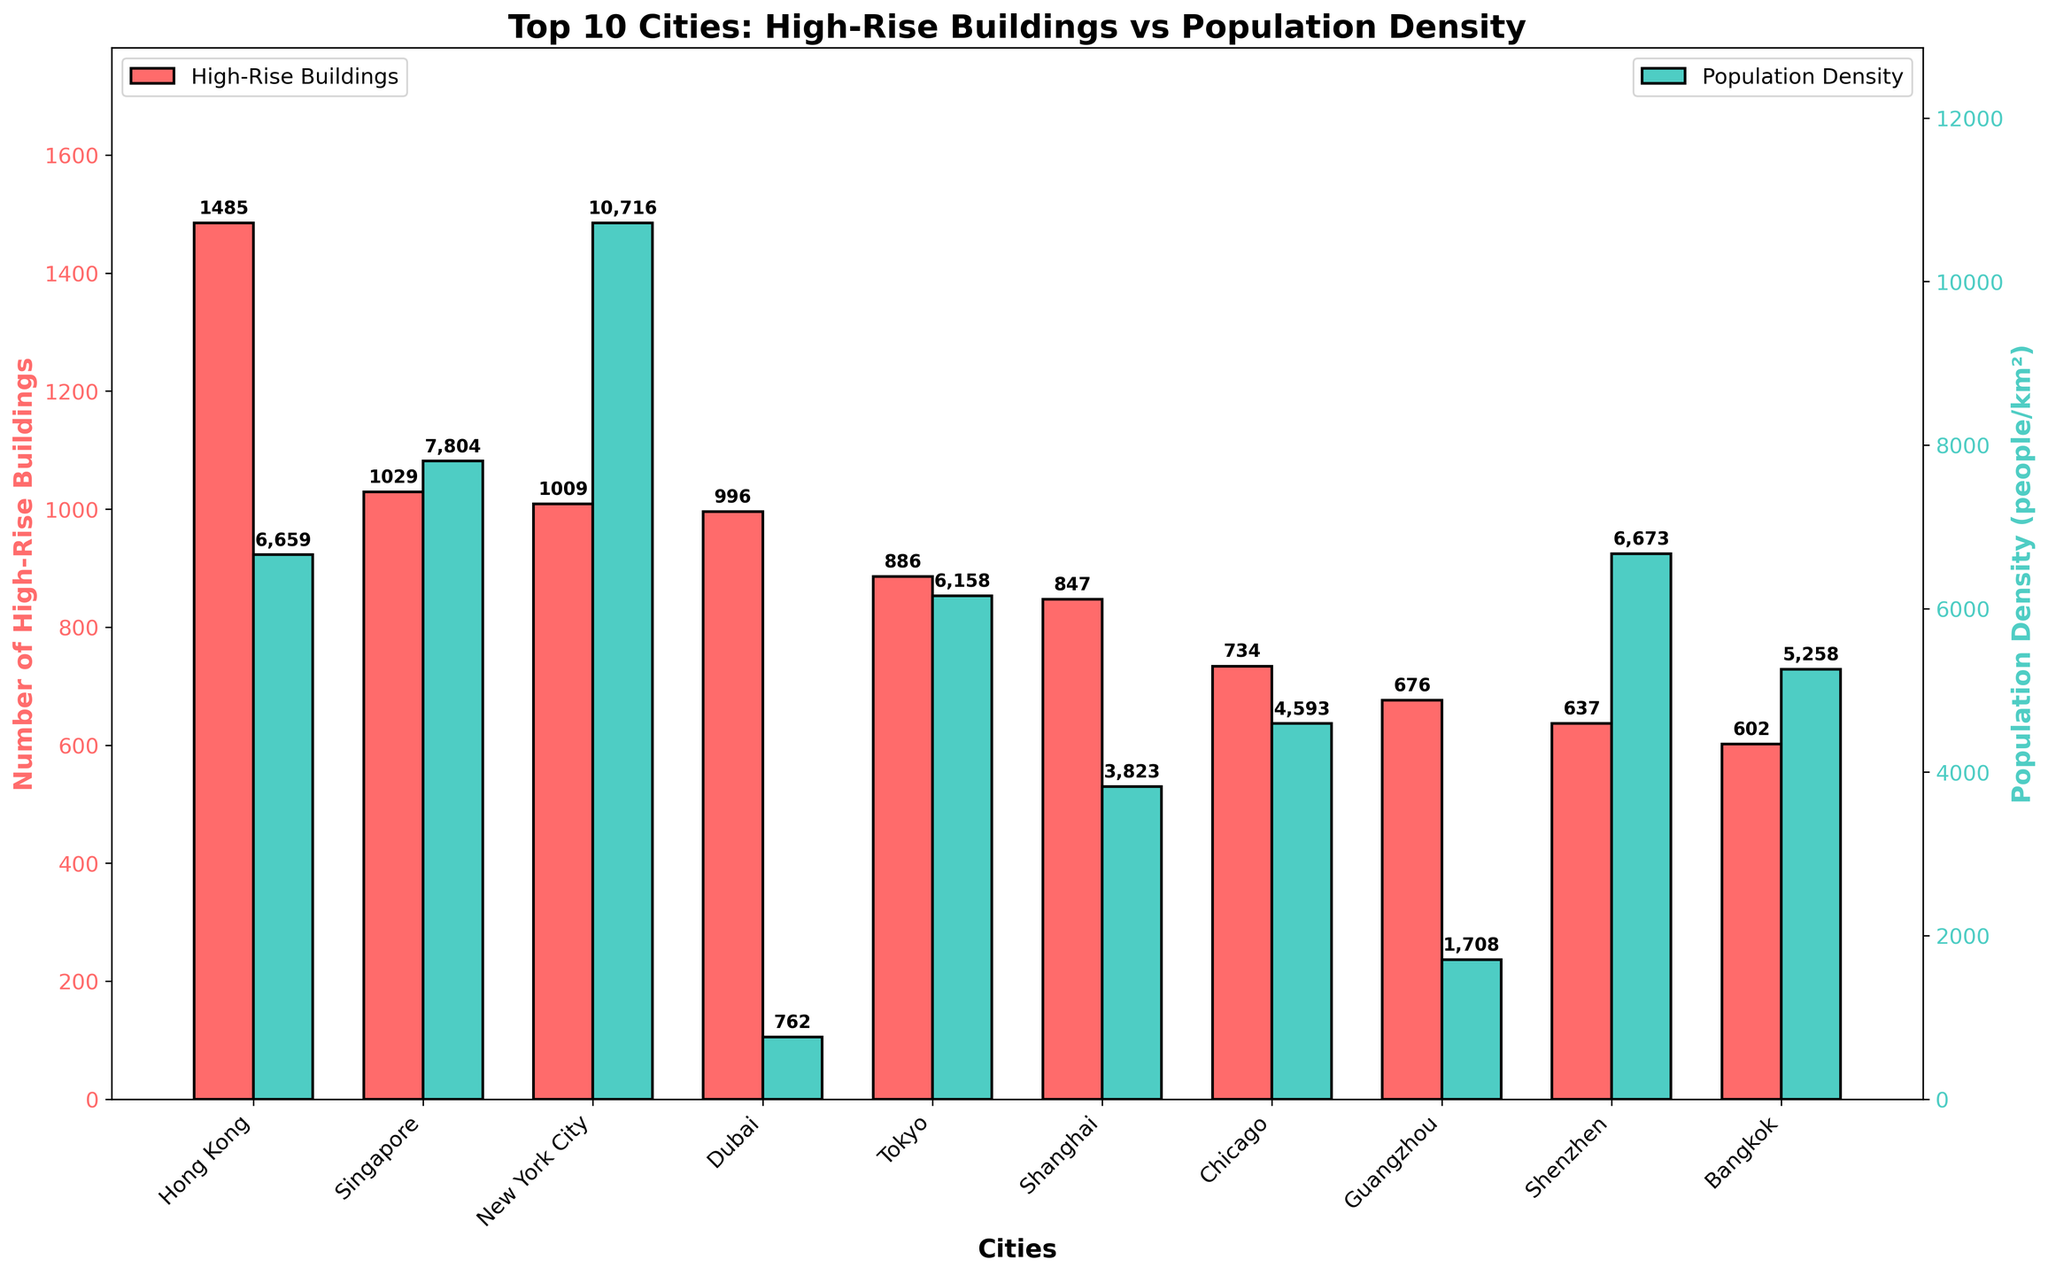Which city has the highest population density among the top 10 cities with the most high-rise buildings? The bar chart shows population density with green bars. Look for the tallest green bar among the cities listed.
Answer: New York City What is the total number of high-rise buildings in Tokyo and Shanghai combined? Add the number of high-rise buildings shown for Tokyo and Shanghai. Tokyo has 886 and Shanghai has 847.
Answer: 1733 Which city has more high-rise buildings, Singapore or Dubai? Compare the heights of the red bars for Singapore and Dubai.
Answer: Singapore Which city has the smallest population density among the top 10 cities with the most high-rise buildings? Identify the shortest green bar.
Answer: Dubai How many more high-rise buildings does Hong Kong have compared to Bangkok? Subtract the number of high-rise buildings in Bangkok from Hong Kong. Hong Kong has 1485, Bangkok has 602.
Answer: 883 Is the population density of Kuala Lumpur higher or lower than that of Shenzhen? Compare the heights of the green bars representing population density for Kuala Lumpur and Shenzhen.
Answer: Lower What is the average population density of the top 10 cities with the most high-rise buildings? Sum the population densities of the 10 cities and divide by 10. (6659 + 7804 + 10716 + 762 + 6158 + 3823 + 4593 + 1708 + 6673 + 5258) / 10 = 6015.4
Answer: 6015.4 Which city has roughly an equal number of high-rise buildings and population density? Look for a city where the height of the red bar (high-rise buildings) is approximately equal to the height of the green bar (population density).
Answer: New York City How many more people per km² does New York City have compared to Chicago? Subtract the population density of Chicago from that of New York City. New York City has 10716, Chicago has 4593.
Answer: 6123 Rank the top three cities in terms of the number of high-rise buildings. Identify and rank the three tallest red bars.
Answer: 1. Hong Kong 2. Singapore 3. New York City 